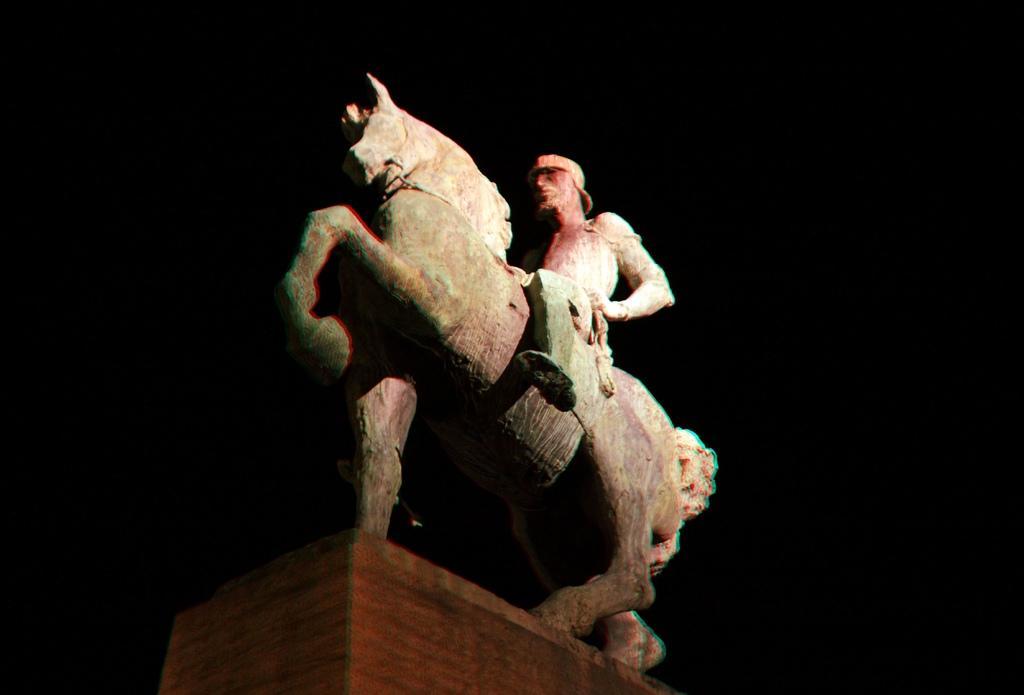Could you give a brief overview of what you see in this image? In this image I can see a horse and a person statue and I can see dark background. 